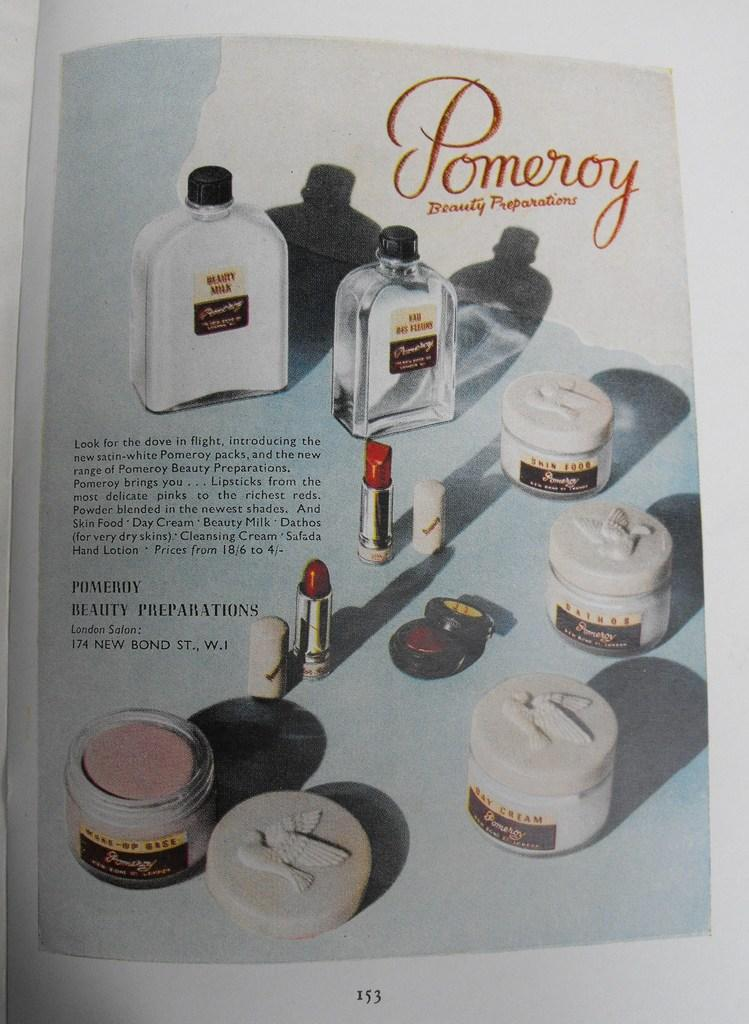<image>
Write a terse but informative summary of the picture. page 153 is a full page ad for pomeroy beauty preparations products 